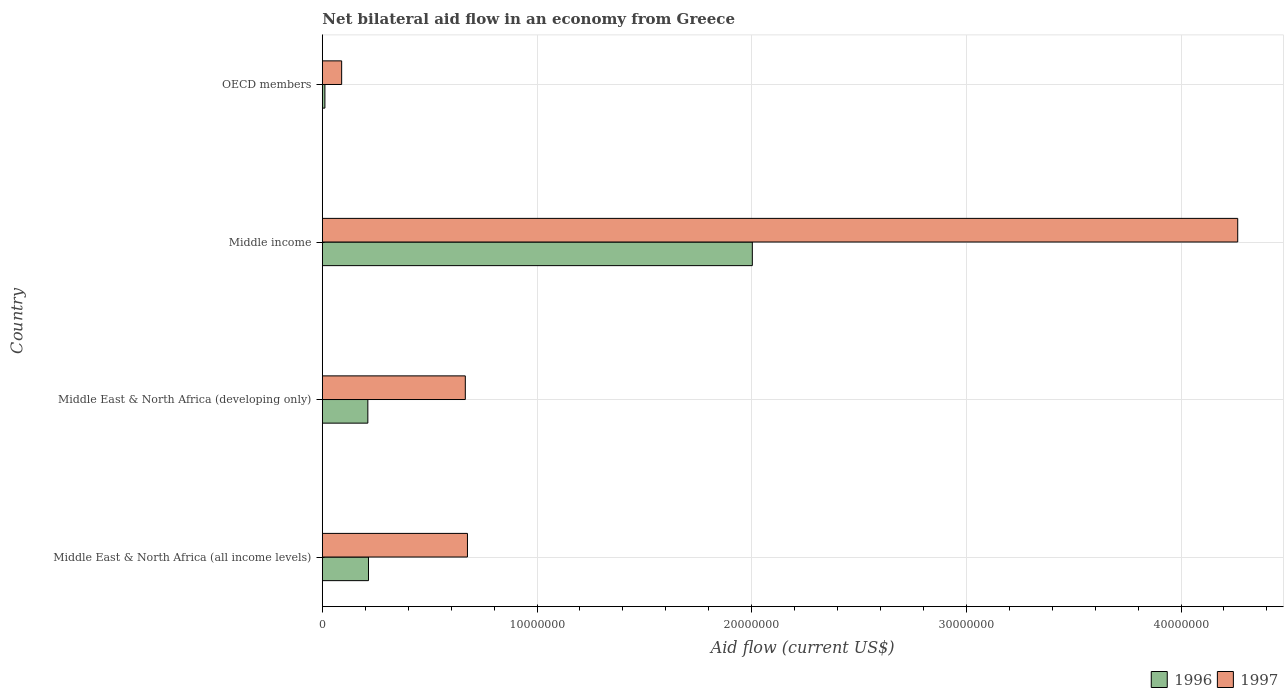Are the number of bars per tick equal to the number of legend labels?
Your answer should be very brief. Yes. How many bars are there on the 1st tick from the top?
Ensure brevity in your answer.  2. What is the label of the 4th group of bars from the top?
Offer a very short reply. Middle East & North Africa (all income levels). In how many cases, is the number of bars for a given country not equal to the number of legend labels?
Provide a short and direct response. 0. What is the net bilateral aid flow in 1997 in Middle East & North Africa (all income levels)?
Your answer should be compact. 6.76e+06. Across all countries, what is the maximum net bilateral aid flow in 1996?
Offer a very short reply. 2.00e+07. Across all countries, what is the minimum net bilateral aid flow in 1996?
Your response must be concise. 1.20e+05. In which country was the net bilateral aid flow in 1997 maximum?
Keep it short and to the point. Middle income. In which country was the net bilateral aid flow in 1997 minimum?
Make the answer very short. OECD members. What is the total net bilateral aid flow in 1997 in the graph?
Your answer should be very brief. 5.70e+07. What is the difference between the net bilateral aid flow in 1996 in Middle East & North Africa (all income levels) and that in OECD members?
Give a very brief answer. 2.03e+06. What is the difference between the net bilateral aid flow in 1996 in Middle East & North Africa (all income levels) and the net bilateral aid flow in 1997 in Middle income?
Your answer should be compact. -4.05e+07. What is the average net bilateral aid flow in 1996 per country?
Offer a very short reply. 6.10e+06. What is the difference between the net bilateral aid flow in 1997 and net bilateral aid flow in 1996 in Middle East & North Africa (developing only)?
Your answer should be compact. 4.54e+06. In how many countries, is the net bilateral aid flow in 1996 greater than 40000000 US$?
Your response must be concise. 0. What is the ratio of the net bilateral aid flow in 1996 in Middle income to that in OECD members?
Offer a terse response. 166.92. Is the net bilateral aid flow in 1996 in Middle East & North Africa (all income levels) less than that in Middle income?
Provide a short and direct response. Yes. What is the difference between the highest and the second highest net bilateral aid flow in 1996?
Provide a short and direct response. 1.79e+07. What is the difference between the highest and the lowest net bilateral aid flow in 1996?
Offer a terse response. 1.99e+07. In how many countries, is the net bilateral aid flow in 1996 greater than the average net bilateral aid flow in 1996 taken over all countries?
Ensure brevity in your answer.  1. What does the 2nd bar from the bottom in Middle income represents?
Your response must be concise. 1997. Are all the bars in the graph horizontal?
Provide a short and direct response. Yes. How many countries are there in the graph?
Provide a succinct answer. 4. What is the difference between two consecutive major ticks on the X-axis?
Ensure brevity in your answer.  1.00e+07. Are the values on the major ticks of X-axis written in scientific E-notation?
Provide a succinct answer. No. Does the graph contain any zero values?
Keep it short and to the point. No. Does the graph contain grids?
Ensure brevity in your answer.  Yes. Where does the legend appear in the graph?
Offer a very short reply. Bottom right. How many legend labels are there?
Your answer should be compact. 2. How are the legend labels stacked?
Keep it short and to the point. Horizontal. What is the title of the graph?
Ensure brevity in your answer.  Net bilateral aid flow in an economy from Greece. Does "1999" appear as one of the legend labels in the graph?
Give a very brief answer. No. What is the label or title of the X-axis?
Offer a terse response. Aid flow (current US$). What is the Aid flow (current US$) of 1996 in Middle East & North Africa (all income levels)?
Offer a terse response. 2.15e+06. What is the Aid flow (current US$) of 1997 in Middle East & North Africa (all income levels)?
Ensure brevity in your answer.  6.76e+06. What is the Aid flow (current US$) in 1996 in Middle East & North Africa (developing only)?
Offer a terse response. 2.12e+06. What is the Aid flow (current US$) of 1997 in Middle East & North Africa (developing only)?
Offer a terse response. 6.66e+06. What is the Aid flow (current US$) of 1996 in Middle income?
Ensure brevity in your answer.  2.00e+07. What is the Aid flow (current US$) of 1997 in Middle income?
Make the answer very short. 4.26e+07. Across all countries, what is the maximum Aid flow (current US$) of 1996?
Your answer should be compact. 2.00e+07. Across all countries, what is the maximum Aid flow (current US$) of 1997?
Ensure brevity in your answer.  4.26e+07. What is the total Aid flow (current US$) of 1996 in the graph?
Make the answer very short. 2.44e+07. What is the total Aid flow (current US$) in 1997 in the graph?
Provide a short and direct response. 5.70e+07. What is the difference between the Aid flow (current US$) of 1997 in Middle East & North Africa (all income levels) and that in Middle East & North Africa (developing only)?
Keep it short and to the point. 1.00e+05. What is the difference between the Aid flow (current US$) of 1996 in Middle East & North Africa (all income levels) and that in Middle income?
Offer a very short reply. -1.79e+07. What is the difference between the Aid flow (current US$) of 1997 in Middle East & North Africa (all income levels) and that in Middle income?
Make the answer very short. -3.59e+07. What is the difference between the Aid flow (current US$) in 1996 in Middle East & North Africa (all income levels) and that in OECD members?
Give a very brief answer. 2.03e+06. What is the difference between the Aid flow (current US$) in 1997 in Middle East & North Africa (all income levels) and that in OECD members?
Ensure brevity in your answer.  5.86e+06. What is the difference between the Aid flow (current US$) in 1996 in Middle East & North Africa (developing only) and that in Middle income?
Your answer should be very brief. -1.79e+07. What is the difference between the Aid flow (current US$) of 1997 in Middle East & North Africa (developing only) and that in Middle income?
Offer a terse response. -3.60e+07. What is the difference between the Aid flow (current US$) in 1997 in Middle East & North Africa (developing only) and that in OECD members?
Your response must be concise. 5.76e+06. What is the difference between the Aid flow (current US$) in 1996 in Middle income and that in OECD members?
Your response must be concise. 1.99e+07. What is the difference between the Aid flow (current US$) in 1997 in Middle income and that in OECD members?
Offer a very short reply. 4.17e+07. What is the difference between the Aid flow (current US$) in 1996 in Middle East & North Africa (all income levels) and the Aid flow (current US$) in 1997 in Middle East & North Africa (developing only)?
Ensure brevity in your answer.  -4.51e+06. What is the difference between the Aid flow (current US$) of 1996 in Middle East & North Africa (all income levels) and the Aid flow (current US$) of 1997 in Middle income?
Your answer should be compact. -4.05e+07. What is the difference between the Aid flow (current US$) of 1996 in Middle East & North Africa (all income levels) and the Aid flow (current US$) of 1997 in OECD members?
Offer a very short reply. 1.25e+06. What is the difference between the Aid flow (current US$) in 1996 in Middle East & North Africa (developing only) and the Aid flow (current US$) in 1997 in Middle income?
Provide a succinct answer. -4.05e+07. What is the difference between the Aid flow (current US$) in 1996 in Middle East & North Africa (developing only) and the Aid flow (current US$) in 1997 in OECD members?
Offer a very short reply. 1.22e+06. What is the difference between the Aid flow (current US$) of 1996 in Middle income and the Aid flow (current US$) of 1997 in OECD members?
Your answer should be compact. 1.91e+07. What is the average Aid flow (current US$) of 1996 per country?
Your response must be concise. 6.10e+06. What is the average Aid flow (current US$) in 1997 per country?
Your response must be concise. 1.42e+07. What is the difference between the Aid flow (current US$) of 1996 and Aid flow (current US$) of 1997 in Middle East & North Africa (all income levels)?
Your answer should be compact. -4.61e+06. What is the difference between the Aid flow (current US$) of 1996 and Aid flow (current US$) of 1997 in Middle East & North Africa (developing only)?
Your answer should be compact. -4.54e+06. What is the difference between the Aid flow (current US$) of 1996 and Aid flow (current US$) of 1997 in Middle income?
Make the answer very short. -2.26e+07. What is the difference between the Aid flow (current US$) of 1996 and Aid flow (current US$) of 1997 in OECD members?
Make the answer very short. -7.80e+05. What is the ratio of the Aid flow (current US$) in 1996 in Middle East & North Africa (all income levels) to that in Middle East & North Africa (developing only)?
Keep it short and to the point. 1.01. What is the ratio of the Aid flow (current US$) of 1996 in Middle East & North Africa (all income levels) to that in Middle income?
Your answer should be compact. 0.11. What is the ratio of the Aid flow (current US$) of 1997 in Middle East & North Africa (all income levels) to that in Middle income?
Your answer should be very brief. 0.16. What is the ratio of the Aid flow (current US$) of 1996 in Middle East & North Africa (all income levels) to that in OECD members?
Give a very brief answer. 17.92. What is the ratio of the Aid flow (current US$) of 1997 in Middle East & North Africa (all income levels) to that in OECD members?
Your answer should be very brief. 7.51. What is the ratio of the Aid flow (current US$) of 1996 in Middle East & North Africa (developing only) to that in Middle income?
Offer a terse response. 0.11. What is the ratio of the Aid flow (current US$) of 1997 in Middle East & North Africa (developing only) to that in Middle income?
Ensure brevity in your answer.  0.16. What is the ratio of the Aid flow (current US$) in 1996 in Middle East & North Africa (developing only) to that in OECD members?
Provide a succinct answer. 17.67. What is the ratio of the Aid flow (current US$) in 1996 in Middle income to that in OECD members?
Make the answer very short. 166.92. What is the ratio of the Aid flow (current US$) of 1997 in Middle income to that in OECD members?
Your answer should be very brief. 47.38. What is the difference between the highest and the second highest Aid flow (current US$) of 1996?
Ensure brevity in your answer.  1.79e+07. What is the difference between the highest and the second highest Aid flow (current US$) of 1997?
Your answer should be very brief. 3.59e+07. What is the difference between the highest and the lowest Aid flow (current US$) in 1996?
Provide a succinct answer. 1.99e+07. What is the difference between the highest and the lowest Aid flow (current US$) in 1997?
Give a very brief answer. 4.17e+07. 